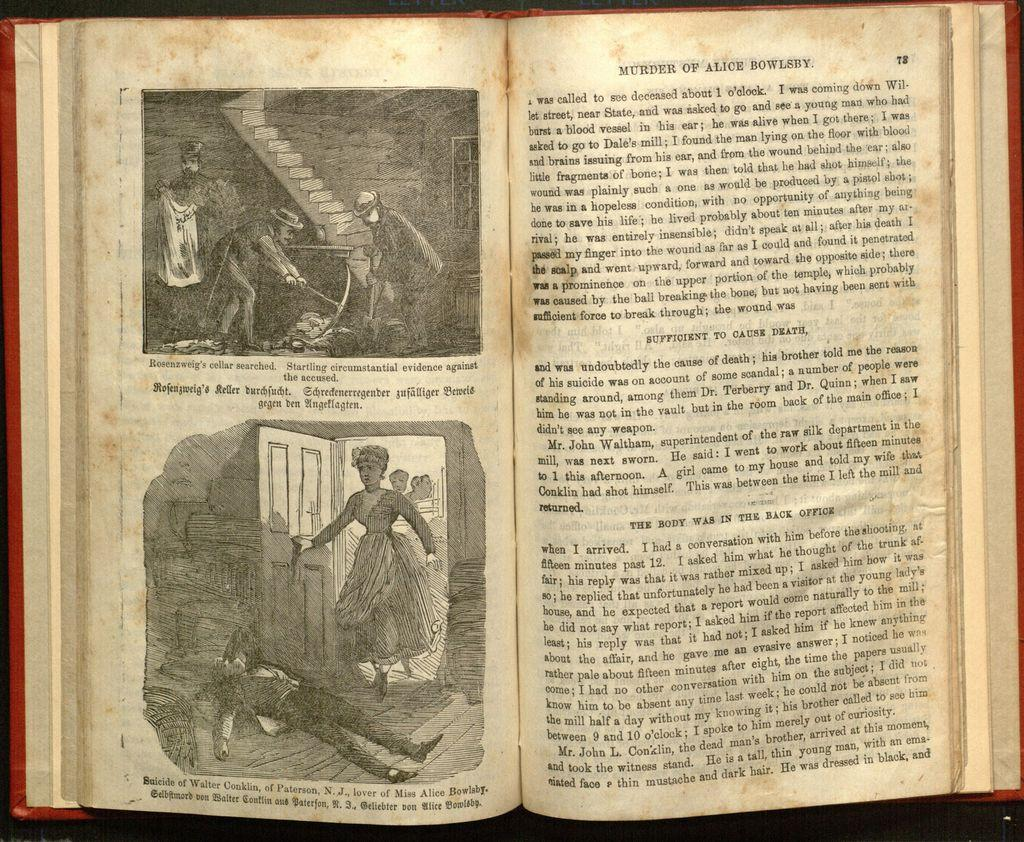<image>
Create a compact narrative representing the image presented. An open book with illustrations on the left page, Rosenzweig's cellar and Suicide of Walter Conklin, and text on the right titled, Murder of Alice Bowlsby. 